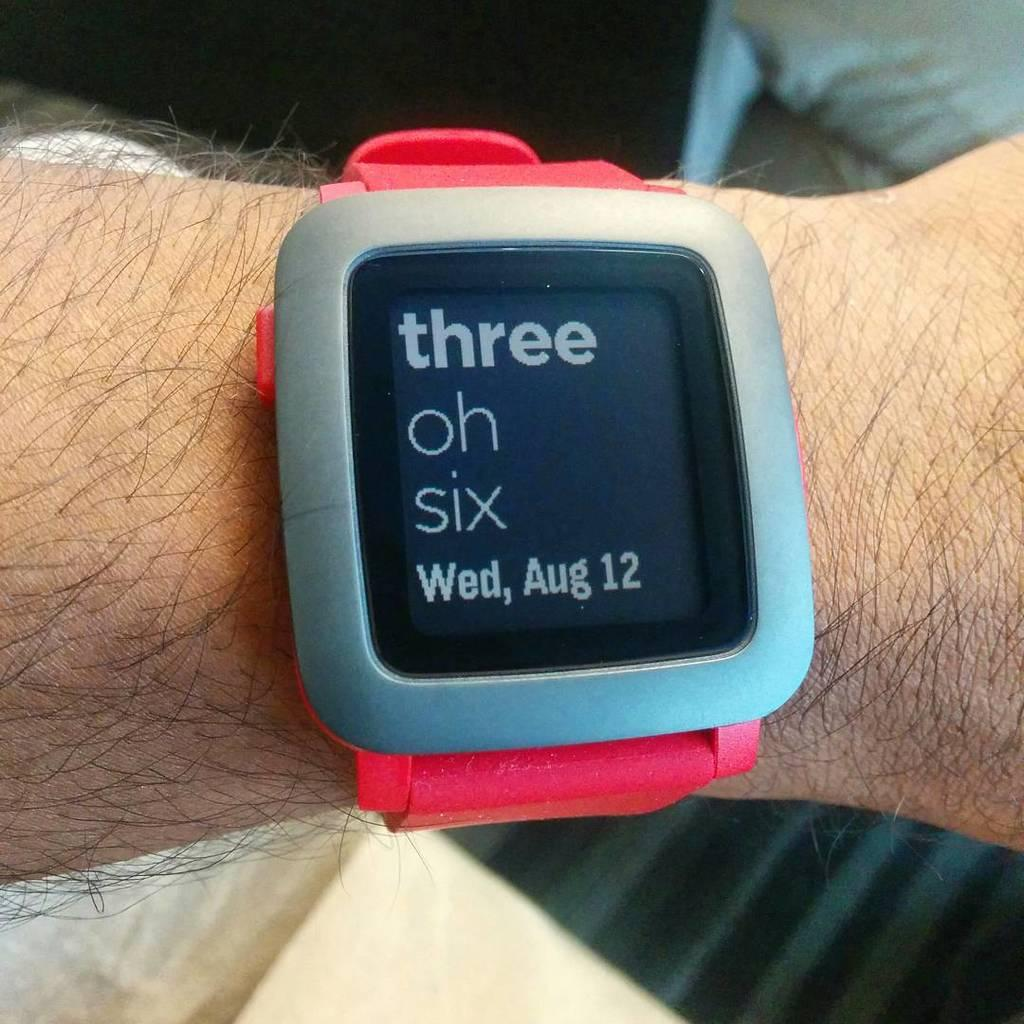<image>
Render a clear and concise summary of the photo. The face of the watch displays the date which is "Wed, Aug 12." 